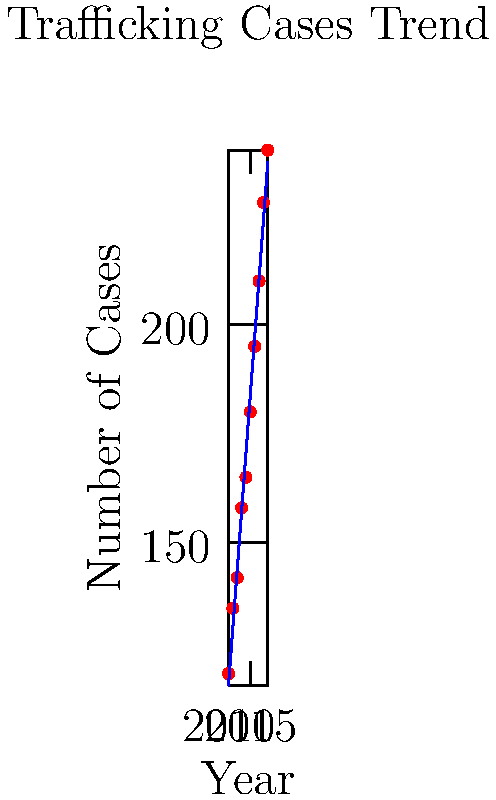As a prosecutor specializing in human trafficking cases, you're analyzing the trend of reported cases over the past decade. The scatter plot shows the number of trafficking cases from 2010 to 2019, with a regression line fitted to the data. Using the regression line, predict the number of trafficking cases for the year 2022. Round your answer to the nearest whole number. To solve this problem, we need to follow these steps:

1. Identify the equation of the regression line:
   The regression line is of the form $y = mx + b$, where $m$ is the slope and $b$ is the y-intercept.

2. Calculate the slope ($m$):
   From the graph, we can estimate that the line passes through approximately (2010, 120) and (2019, 240).
   $m = \frac{y_2 - y_1}{x_2 - x_1} = \frac{240 - 120}{2019 - 2010} = \frac{120}{9} \approx 13.33$

3. Calculate the y-intercept ($b$):
   Using the point (2010, 120) and the slope, we can calculate $b$:
   $120 = 13.33 * 2010 + b$
   $b = 120 - 13.33 * 2010 = -26693.3$

4. Write the equation of the regression line:
   $y = 13.33x - 26693.3$

5. Predict the number of cases for 2022:
   $y = 13.33 * 2022 - 26693.3 = 269.06$

6. Round to the nearest whole number:
   269

Therefore, based on the regression line, we predict approximately 269 trafficking cases for the year 2022.
Answer: 269 